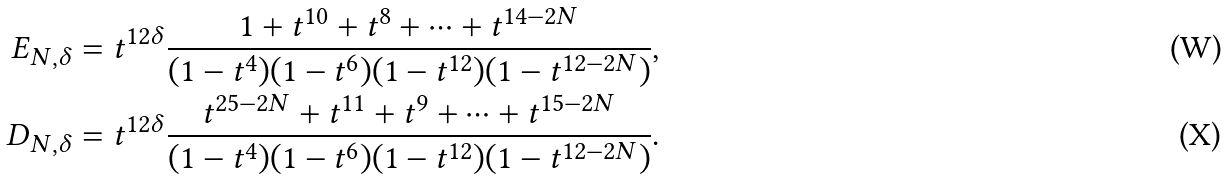Convert formula to latex. <formula><loc_0><loc_0><loc_500><loc_500>E _ { N , \delta } & = t ^ { 1 2 \delta } \frac { 1 + t ^ { 1 0 } + t ^ { 8 } + \dots + t ^ { 1 4 - 2 N } } { ( 1 - t ^ { 4 } ) ( 1 - t ^ { 6 } ) ( 1 - t ^ { 1 2 } ) ( 1 - t ^ { 1 2 - 2 N } ) } , \\ D _ { N , \delta } & = t ^ { 1 2 \delta } \frac { t ^ { 2 5 - 2 N } + t ^ { 1 1 } + t ^ { 9 } + \dots + t ^ { 1 5 - 2 N } } { ( 1 - t ^ { 4 } ) ( 1 - t ^ { 6 } ) ( 1 - t ^ { 1 2 } ) ( 1 - t ^ { 1 2 - 2 N } ) } .</formula> 